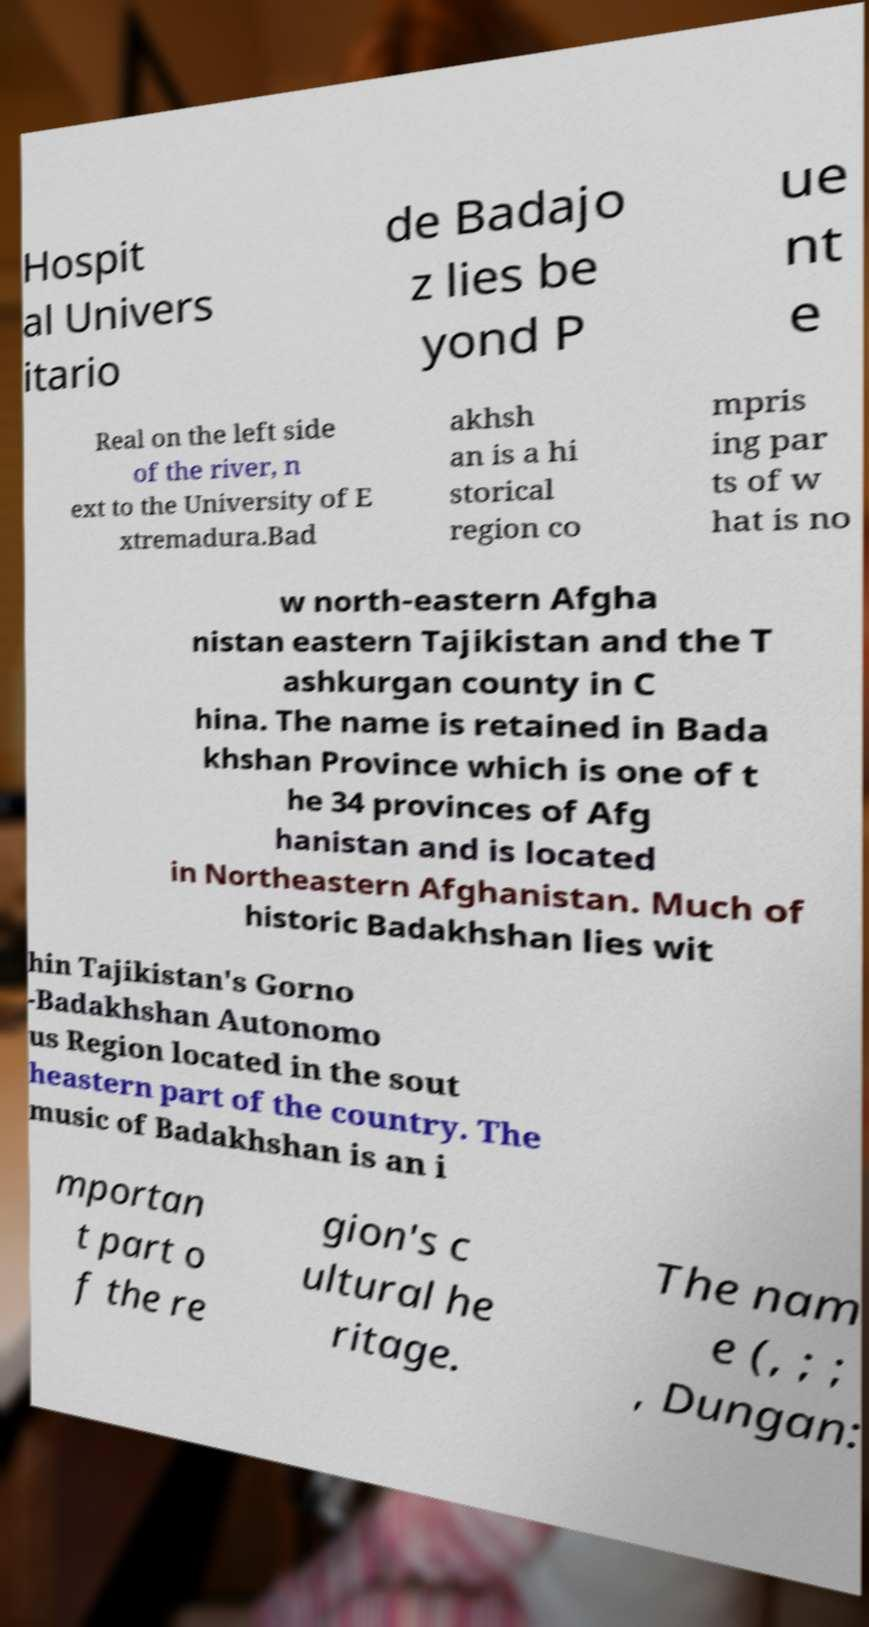For documentation purposes, I need the text within this image transcribed. Could you provide that? Hospit al Univers itario de Badajo z lies be yond P ue nt e Real on the left side of the river, n ext to the University of E xtremadura.Bad akhsh an is a hi storical region co mpris ing par ts of w hat is no w north-eastern Afgha nistan eastern Tajikistan and the T ashkurgan county in C hina. The name is retained in Bada khshan Province which is one of t he 34 provinces of Afg hanistan and is located in Northeastern Afghanistan. Much of historic Badakhshan lies wit hin Tajikistan's Gorno -Badakhshan Autonomo us Region located in the sout heastern part of the country. The music of Badakhshan is an i mportan t part o f the re gion's c ultural he ritage. The nam e (, ; ; , Dungan: 